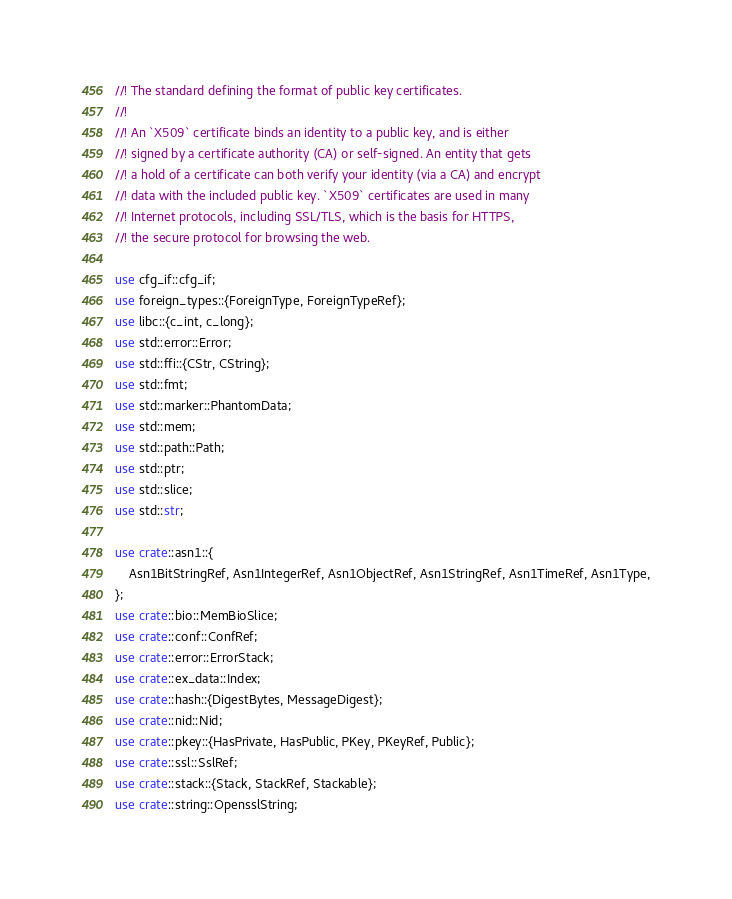Convert code to text. <code><loc_0><loc_0><loc_500><loc_500><_Rust_>//! The standard defining the format of public key certificates.
//!
//! An `X509` certificate binds an identity to a public key, and is either
//! signed by a certificate authority (CA) or self-signed. An entity that gets
//! a hold of a certificate can both verify your identity (via a CA) and encrypt
//! data with the included public key. `X509` certificates are used in many
//! Internet protocols, including SSL/TLS, which is the basis for HTTPS,
//! the secure protocol for browsing the web.

use cfg_if::cfg_if;
use foreign_types::{ForeignType, ForeignTypeRef};
use libc::{c_int, c_long};
use std::error::Error;
use std::ffi::{CStr, CString};
use std::fmt;
use std::marker::PhantomData;
use std::mem;
use std::path::Path;
use std::ptr;
use std::slice;
use std::str;

use crate::asn1::{
    Asn1BitStringRef, Asn1IntegerRef, Asn1ObjectRef, Asn1StringRef, Asn1TimeRef, Asn1Type,
};
use crate::bio::MemBioSlice;
use crate::conf::ConfRef;
use crate::error::ErrorStack;
use crate::ex_data::Index;
use crate::hash::{DigestBytes, MessageDigest};
use crate::nid::Nid;
use crate::pkey::{HasPrivate, HasPublic, PKey, PKeyRef, Public};
use crate::ssl::SslRef;
use crate::stack::{Stack, StackRef, Stackable};
use crate::string::OpensslString;</code> 